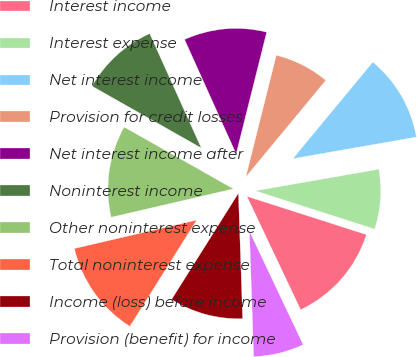Convert chart. <chart><loc_0><loc_0><loc_500><loc_500><pie_chart><fcel>Interest income<fcel>Interest expense<fcel>Net interest income<fcel>Provision for credit losses<fcel>Net interest income after<fcel>Noninterest income<fcel>Other noninterest expense<fcel>Total noninterest expense<fcel>Income (loss) before income<fcel>Provision (benefit) for income<nl><fcel>13.02%<fcel>7.69%<fcel>11.24%<fcel>7.1%<fcel>10.65%<fcel>10.06%<fcel>11.83%<fcel>12.43%<fcel>9.47%<fcel>6.51%<nl></chart> 